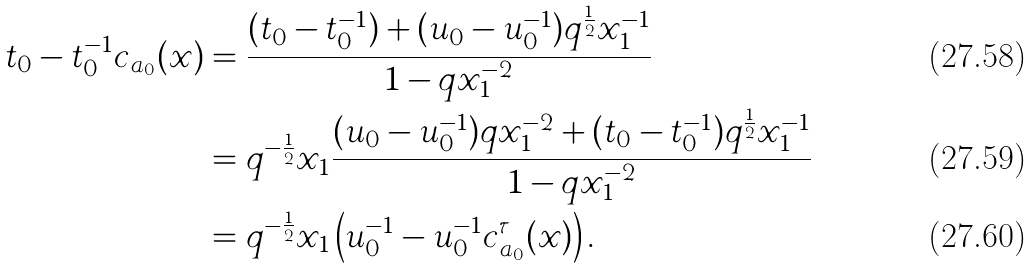<formula> <loc_0><loc_0><loc_500><loc_500>t _ { 0 } - t _ { 0 } ^ { - 1 } c _ { a _ { 0 } } ( x ) & = \frac { ( t _ { 0 } - t _ { 0 } ^ { - 1 } ) + ( u _ { 0 } - u _ { 0 } ^ { - 1 } ) q ^ { \frac { 1 } { 2 } } x _ { 1 } ^ { - 1 } } { 1 - q x _ { 1 } ^ { - 2 } } \\ & = q ^ { - \frac { 1 } { 2 } } x _ { 1 } \frac { ( u _ { 0 } - u _ { 0 } ^ { - 1 } ) q x _ { 1 } ^ { - 2 } + ( t _ { 0 } - t _ { 0 } ^ { - 1 } ) q ^ { \frac { 1 } { 2 } } x _ { 1 } ^ { - 1 } } { 1 - q x _ { 1 } ^ { - 2 } } \\ & = q ^ { - \frac { 1 } { 2 } } x _ { 1 } \left ( u _ { 0 } ^ { - 1 } - u _ { 0 } ^ { - 1 } c _ { a _ { 0 } } ^ { \tau } ( x ) \right ) .</formula> 